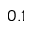Convert formula to latex. <formula><loc_0><loc_0><loc_500><loc_500>0 . 1</formula> 